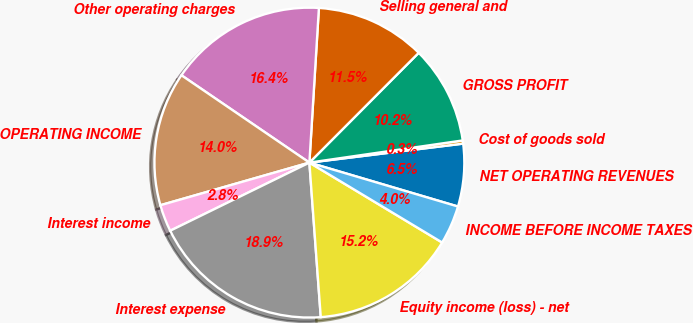Convert chart to OTSL. <chart><loc_0><loc_0><loc_500><loc_500><pie_chart><fcel>NET OPERATING REVENUES<fcel>Cost of goods sold<fcel>GROSS PROFIT<fcel>Selling general and<fcel>Other operating charges<fcel>OPERATING INCOME<fcel>Interest income<fcel>Interest expense<fcel>Equity income (loss) - net<fcel>INCOME BEFORE INCOME TAXES<nl><fcel>6.53%<fcel>0.33%<fcel>10.25%<fcel>11.49%<fcel>16.45%<fcel>13.97%<fcel>2.81%<fcel>18.93%<fcel>15.21%<fcel>4.05%<nl></chart> 